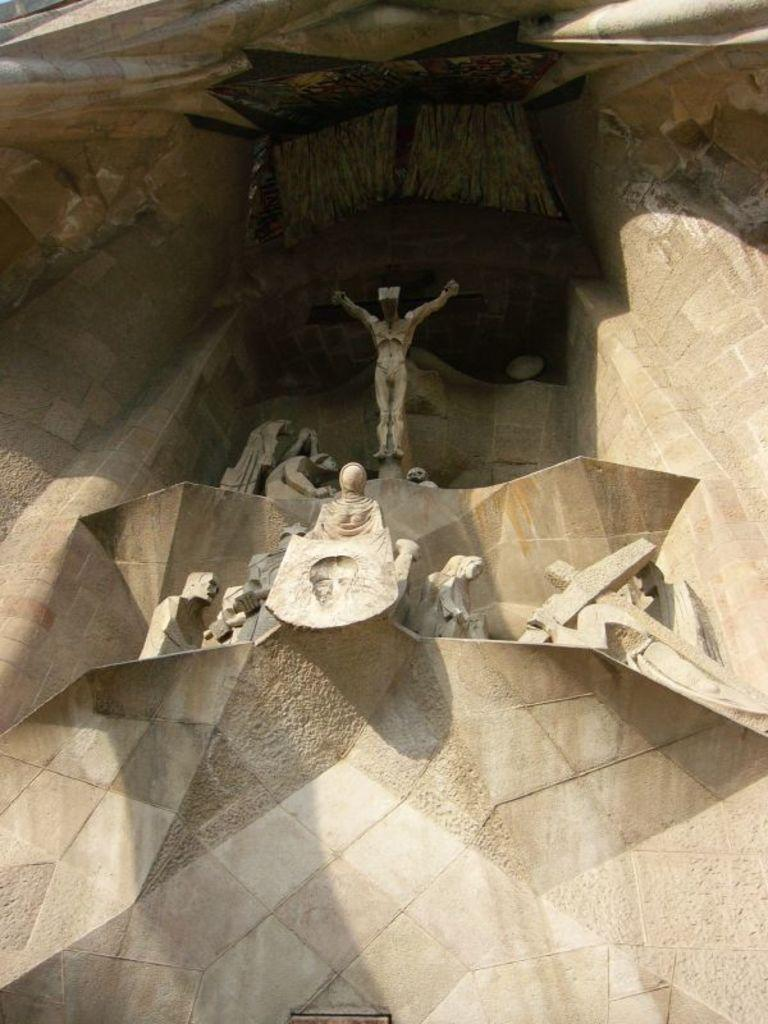What is the main structure visible in the image? There is a monument in the image. What can be seen at the top of the monument? There are sculptures at the top of the monument. What type of line can be seen connecting the sculptures on the monument? There is no line connecting the sculptures on the monument in the image. 